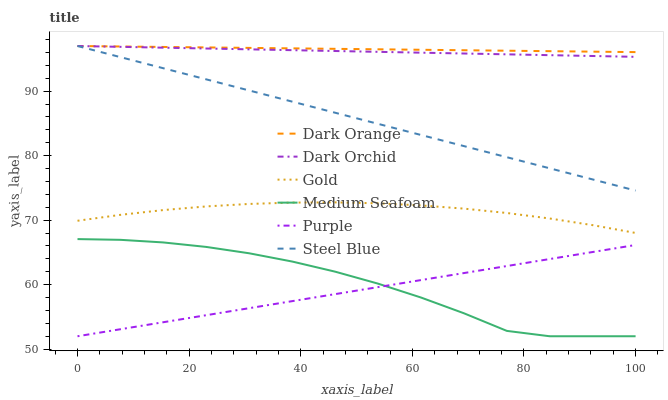Does Purple have the minimum area under the curve?
Answer yes or no. Yes. Does Dark Orange have the maximum area under the curve?
Answer yes or no. Yes. Does Gold have the minimum area under the curve?
Answer yes or no. No. Does Gold have the maximum area under the curve?
Answer yes or no. No. Is Purple the smoothest?
Answer yes or no. Yes. Is Medium Seafoam the roughest?
Answer yes or no. Yes. Is Gold the smoothest?
Answer yes or no. No. Is Gold the roughest?
Answer yes or no. No. Does Purple have the lowest value?
Answer yes or no. Yes. Does Gold have the lowest value?
Answer yes or no. No. Does Dark Orchid have the highest value?
Answer yes or no. Yes. Does Gold have the highest value?
Answer yes or no. No. Is Gold less than Steel Blue?
Answer yes or no. Yes. Is Steel Blue greater than Medium Seafoam?
Answer yes or no. Yes. Does Steel Blue intersect Dark Orange?
Answer yes or no. Yes. Is Steel Blue less than Dark Orange?
Answer yes or no. No. Is Steel Blue greater than Dark Orange?
Answer yes or no. No. Does Gold intersect Steel Blue?
Answer yes or no. No. 